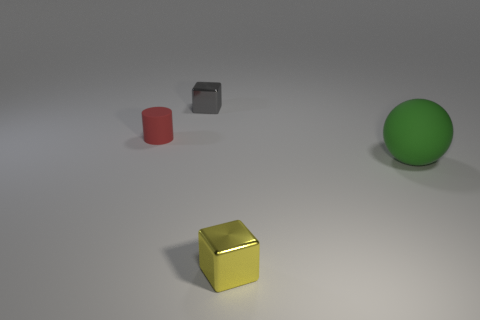Add 2 large green things. How many objects exist? 6 Subtract all cylinders. How many objects are left? 3 Subtract all green matte objects. Subtract all yellow shiny objects. How many objects are left? 2 Add 4 big green matte spheres. How many big green matte spheres are left? 5 Add 1 small cyan objects. How many small cyan objects exist? 1 Subtract 0 green blocks. How many objects are left? 4 